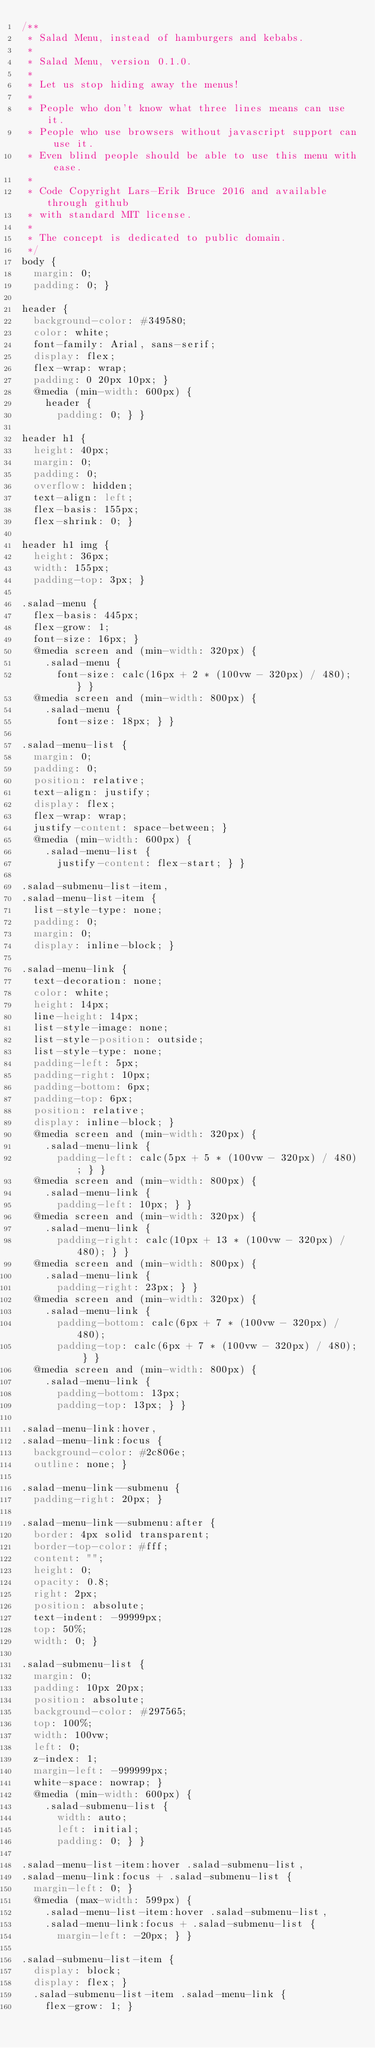Convert code to text. <code><loc_0><loc_0><loc_500><loc_500><_CSS_>/**
 * Salad Menu, instead of hamburgers and kebabs.
 *
 * Salad Menu, version 0.1.0.
 *
 * Let us stop hiding away the menus!
 *
 * People who don't know what three lines means can use it.
 * People who use browsers without javascript support can use it.
 * Even blind people should be able to use this menu with ease.
 *
 * Code Copyright Lars-Erik Bruce 2016 and available through github
 * with standard MIT license.
 *
 * The concept is dedicated to public domain.
 */
body {
  margin: 0;
  padding: 0; }

header {
  background-color: #349580;
  color: white;
  font-family: Arial, sans-serif;
  display: flex;
  flex-wrap: wrap;
  padding: 0 20px 10px; }
  @media (min-width: 600px) {
    header {
      padding: 0; } }

header h1 {
  height: 40px;
  margin: 0;
  padding: 0;
  overflow: hidden;
  text-align: left;
  flex-basis: 155px;
  flex-shrink: 0; }

header h1 img {
  height: 36px;
  width: 155px;
  padding-top: 3px; }

.salad-menu {
  flex-basis: 445px;
  flex-grow: 1;
  font-size: 16px; }
  @media screen and (min-width: 320px) {
    .salad-menu {
      font-size: calc(16px + 2 * (100vw - 320px) / 480); } }
  @media screen and (min-width: 800px) {
    .salad-menu {
      font-size: 18px; } }

.salad-menu-list {
  margin: 0;
  padding: 0;
  position: relative;
  text-align: justify;
  display: flex;
  flex-wrap: wrap;
  justify-content: space-between; }
  @media (min-width: 600px) {
    .salad-menu-list {
      justify-content: flex-start; } }

.salad-submenu-list-item,
.salad-menu-list-item {
  list-style-type: none;
  padding: 0;
  margin: 0;
  display: inline-block; }

.salad-menu-link {
  text-decoration: none;
  color: white;
  height: 14px;
  line-height: 14px;
  list-style-image: none;
  list-style-position: outside;
  list-style-type: none;
  padding-left: 5px;
  padding-right: 10px;
  padding-bottom: 6px;
  padding-top: 6px;
  position: relative;
  display: inline-block; }
  @media screen and (min-width: 320px) {
    .salad-menu-link {
      padding-left: calc(5px + 5 * (100vw - 320px) / 480); } }
  @media screen and (min-width: 800px) {
    .salad-menu-link {
      padding-left: 10px; } }
  @media screen and (min-width: 320px) {
    .salad-menu-link {
      padding-right: calc(10px + 13 * (100vw - 320px) / 480); } }
  @media screen and (min-width: 800px) {
    .salad-menu-link {
      padding-right: 23px; } }
  @media screen and (min-width: 320px) {
    .salad-menu-link {
      padding-bottom: calc(6px + 7 * (100vw - 320px) / 480);
      padding-top: calc(6px + 7 * (100vw - 320px) / 480); } }
  @media screen and (min-width: 800px) {
    .salad-menu-link {
      padding-bottom: 13px;
      padding-top: 13px; } }

.salad-menu-link:hover,
.salad-menu-link:focus {
  background-color: #2c806e;
  outline: none; }

.salad-menu-link--submenu {
  padding-right: 20px; }

.salad-menu-link--submenu:after {
  border: 4px solid transparent;
  border-top-color: #fff;
  content: "";
  height: 0;
  opacity: 0.8;
  right: 2px;
  position: absolute;
  text-indent: -99999px;
  top: 50%;
  width: 0; }

.salad-submenu-list {
  margin: 0;
  padding: 10px 20px;
  position: absolute;
  background-color: #297565;
  top: 100%;
  width: 100vw;
  left: 0;
  z-index: 1;
  margin-left: -999999px;
  white-space: nowrap; }
  @media (min-width: 600px) {
    .salad-submenu-list {
      width: auto;
      left: initial;
      padding: 0; } }

.salad-menu-list-item:hover .salad-submenu-list,
.salad-menu-link:focus + .salad-submenu-list {
  margin-left: 0; }
  @media (max-width: 599px) {
    .salad-menu-list-item:hover .salad-submenu-list,
    .salad-menu-link:focus + .salad-submenu-list {
      margin-left: -20px; } }

.salad-submenu-list-item {
  display: block;
  display: flex; }
  .salad-submenu-list-item .salad-menu-link {
    flex-grow: 1; }
</code> 